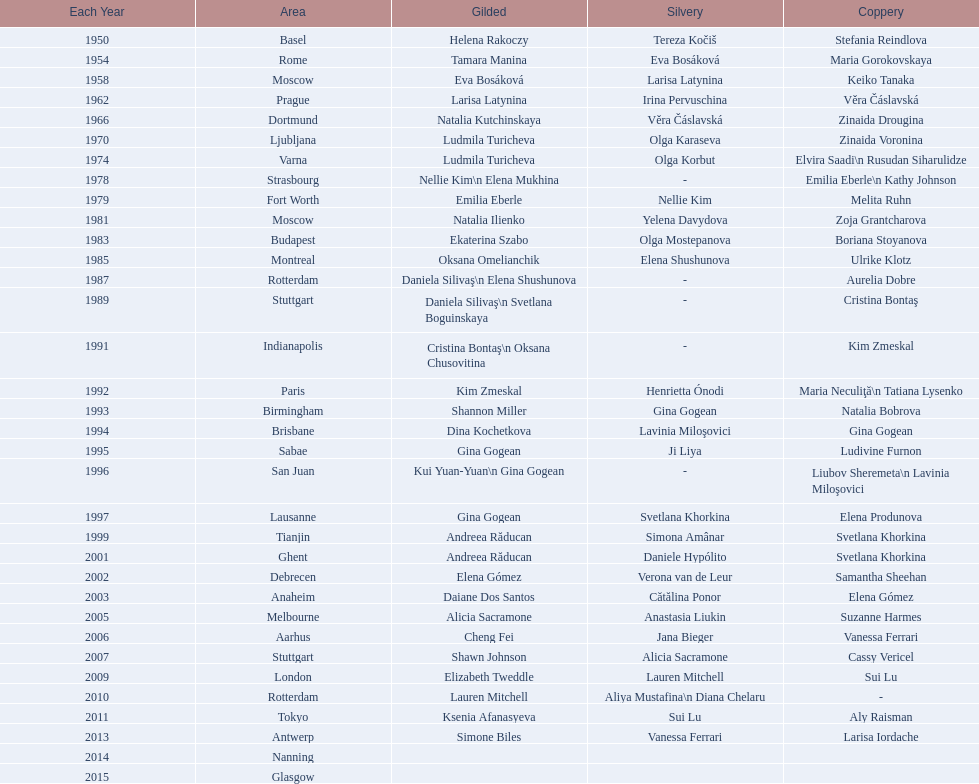I'm looking to parse the entire table for insights. Could you assist me with that? {'header': ['Each Year', 'Area', 'Gilded', 'Silvery', 'Coppery'], 'rows': [['1950', 'Basel', 'Helena Rakoczy', 'Tereza Kočiš', 'Stefania Reindlova'], ['1954', 'Rome', 'Tamara Manina', 'Eva Bosáková', 'Maria Gorokovskaya'], ['1958', 'Moscow', 'Eva Bosáková', 'Larisa Latynina', 'Keiko Tanaka'], ['1962', 'Prague', 'Larisa Latynina', 'Irina Pervuschina', 'Věra Čáslavská'], ['1966', 'Dortmund', 'Natalia Kutchinskaya', 'Věra Čáslavská', 'Zinaida Drougina'], ['1970', 'Ljubljana', 'Ludmila Turicheva', 'Olga Karaseva', 'Zinaida Voronina'], ['1974', 'Varna', 'Ludmila Turicheva', 'Olga Korbut', 'Elvira Saadi\\n Rusudan Siharulidze'], ['1978', 'Strasbourg', 'Nellie Kim\\n Elena Mukhina', '-', 'Emilia Eberle\\n Kathy Johnson'], ['1979', 'Fort Worth', 'Emilia Eberle', 'Nellie Kim', 'Melita Ruhn'], ['1981', 'Moscow', 'Natalia Ilienko', 'Yelena Davydova', 'Zoja Grantcharova'], ['1983', 'Budapest', 'Ekaterina Szabo', 'Olga Mostepanova', 'Boriana Stoyanova'], ['1985', 'Montreal', 'Oksana Omelianchik', 'Elena Shushunova', 'Ulrike Klotz'], ['1987', 'Rotterdam', 'Daniela Silivaş\\n Elena Shushunova', '-', 'Aurelia Dobre'], ['1989', 'Stuttgart', 'Daniela Silivaş\\n Svetlana Boguinskaya', '-', 'Cristina Bontaş'], ['1991', 'Indianapolis', 'Cristina Bontaş\\n Oksana Chusovitina', '-', 'Kim Zmeskal'], ['1992', 'Paris', 'Kim Zmeskal', 'Henrietta Ónodi', 'Maria Neculiţă\\n Tatiana Lysenko'], ['1993', 'Birmingham', 'Shannon Miller', 'Gina Gogean', 'Natalia Bobrova'], ['1994', 'Brisbane', 'Dina Kochetkova', 'Lavinia Miloşovici', 'Gina Gogean'], ['1995', 'Sabae', 'Gina Gogean', 'Ji Liya', 'Ludivine Furnon'], ['1996', 'San Juan', 'Kui Yuan-Yuan\\n Gina Gogean', '-', 'Liubov Sheremeta\\n Lavinia Miloşovici'], ['1997', 'Lausanne', 'Gina Gogean', 'Svetlana Khorkina', 'Elena Produnova'], ['1999', 'Tianjin', 'Andreea Răducan', 'Simona Amânar', 'Svetlana Khorkina'], ['2001', 'Ghent', 'Andreea Răducan', 'Daniele Hypólito', 'Svetlana Khorkina'], ['2002', 'Debrecen', 'Elena Gómez', 'Verona van de Leur', 'Samantha Sheehan'], ['2003', 'Anaheim', 'Daiane Dos Santos', 'Cătălina Ponor', 'Elena Gómez'], ['2005', 'Melbourne', 'Alicia Sacramone', 'Anastasia Liukin', 'Suzanne Harmes'], ['2006', 'Aarhus', 'Cheng Fei', 'Jana Bieger', 'Vanessa Ferrari'], ['2007', 'Stuttgart', 'Shawn Johnson', 'Alicia Sacramone', 'Cassy Vericel'], ['2009', 'London', 'Elizabeth Tweddle', 'Lauren Mitchell', 'Sui Lu'], ['2010', 'Rotterdam', 'Lauren Mitchell', 'Aliya Mustafina\\n Diana Chelaru', '-'], ['2011', 'Tokyo', 'Ksenia Afanasyeva', 'Sui Lu', 'Aly Raisman'], ['2013', 'Antwerp', 'Simone Biles', 'Vanessa Ferrari', 'Larisa Iordache'], ['2014', 'Nanning', '', '', ''], ['2015', 'Glasgow', '', '', '']]} How many times was the world artistic gymnastics championships held in the united states? 3. 